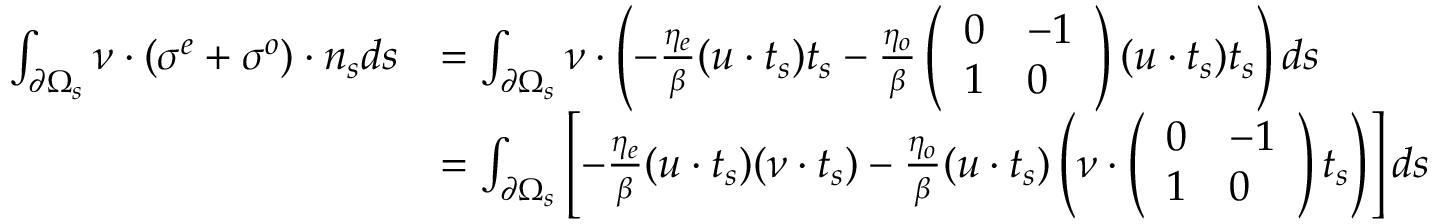<formula> <loc_0><loc_0><loc_500><loc_500>\begin{array} { r l } { \int _ { \partial \Omega _ { s } } \nu \cdot ( \sigma ^ { e } + \sigma ^ { o } ) \cdot n _ { s } d s } & { = \int _ { \partial \Omega _ { s } } \nu \cdot \left ( - \frac { \eta _ { e } } { \beta } ( u \cdot t _ { s } ) t _ { s } - \frac { \eta _ { o } } { \beta } \left ( \begin{array} { l l } { 0 } & { - 1 } \\ { 1 } & { 0 } \end{array} \right ) ( u \cdot t _ { s } ) t _ { s } \right ) d s } \\ & { = \int _ { \partial \Omega _ { s } } \left [ - \frac { \eta _ { e } } { \beta } ( u \cdot t _ { s } ) ( \nu \cdot t _ { s } ) - \frac { \eta _ { o } } { \beta } ( u \cdot t _ { s } ) \left ( \nu \cdot \left ( \begin{array} { l l } { 0 } & { - 1 } \\ { 1 } & { 0 } \end{array} \right ) t _ { s } \right ) \right ] d s } \end{array}</formula> 